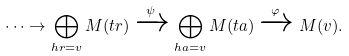Convert formula to latex. <formula><loc_0><loc_0><loc_500><loc_500>\cdots \to \bigoplus _ { h r = v } M ( t r ) \xrightarrow { \psi } \bigoplus _ { h a = v } M ( t a ) \xrightarrow { \varphi } M ( v ) .</formula> 